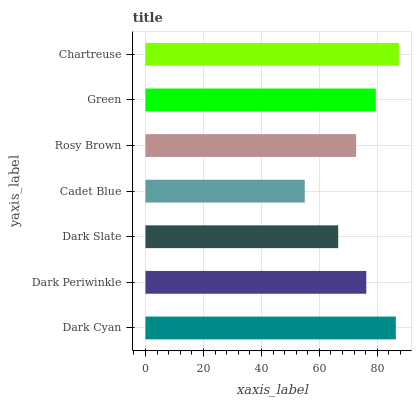Is Cadet Blue the minimum?
Answer yes or no. Yes. Is Chartreuse the maximum?
Answer yes or no. Yes. Is Dark Periwinkle the minimum?
Answer yes or no. No. Is Dark Periwinkle the maximum?
Answer yes or no. No. Is Dark Cyan greater than Dark Periwinkle?
Answer yes or no. Yes. Is Dark Periwinkle less than Dark Cyan?
Answer yes or no. Yes. Is Dark Periwinkle greater than Dark Cyan?
Answer yes or no. No. Is Dark Cyan less than Dark Periwinkle?
Answer yes or no. No. Is Dark Periwinkle the high median?
Answer yes or no. Yes. Is Dark Periwinkle the low median?
Answer yes or no. Yes. Is Dark Slate the high median?
Answer yes or no. No. Is Dark Cyan the low median?
Answer yes or no. No. 